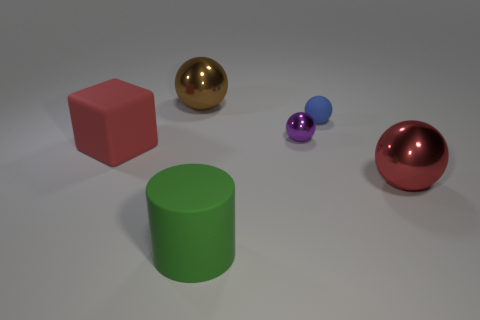Add 1 green spheres. How many objects exist? 7 Subtract all big red metallic balls. How many balls are left? 3 Subtract 2 balls. How many balls are left? 2 Subtract all balls. How many objects are left? 2 Subtract all purple balls. How many balls are left? 3 Subtract 1 brown balls. How many objects are left? 5 Subtract all blue cylinders. Subtract all green cubes. How many cylinders are left? 1 Subtract all big shiny things. Subtract all small metallic things. How many objects are left? 3 Add 4 purple balls. How many purple balls are left? 5 Add 5 big blue shiny objects. How many big blue shiny objects exist? 5 